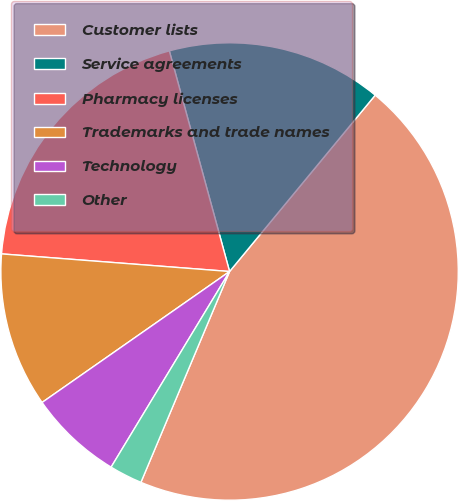Convert chart to OTSL. <chart><loc_0><loc_0><loc_500><loc_500><pie_chart><fcel>Customer lists<fcel>Service agreements<fcel>Pharmacy licenses<fcel>Trademarks and trade names<fcel>Technology<fcel>Other<nl><fcel>45.35%<fcel>15.23%<fcel>19.53%<fcel>10.93%<fcel>6.63%<fcel>2.33%<nl></chart> 